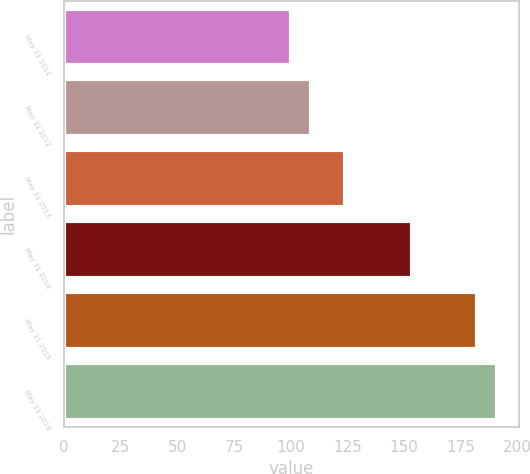Convert chart. <chart><loc_0><loc_0><loc_500><loc_500><bar_chart><fcel>May 31 2011<fcel>May 31 2012<fcel>May 31 2013<fcel>May 31 2014<fcel>May 31 2015<fcel>May 31 2016<nl><fcel>100<fcel>108.8<fcel>123.83<fcel>153.42<fcel>182.29<fcel>191.09<nl></chart> 